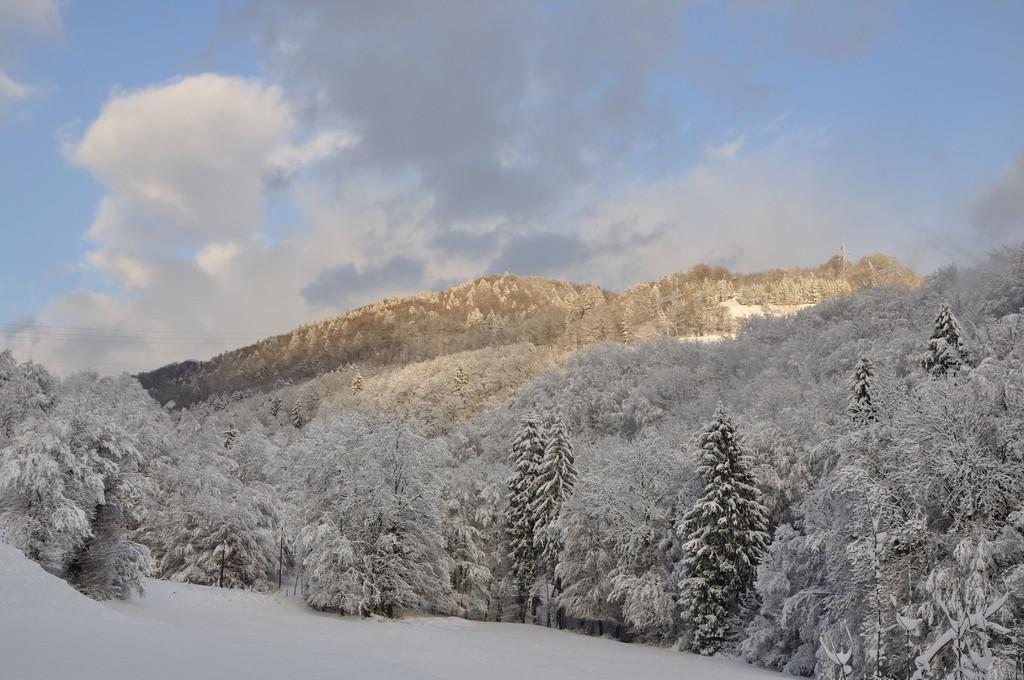Please provide a concise description of this image. In this image we can see a group of trees covered with snow. In the background, we can see mountains and the cloudy sky. 